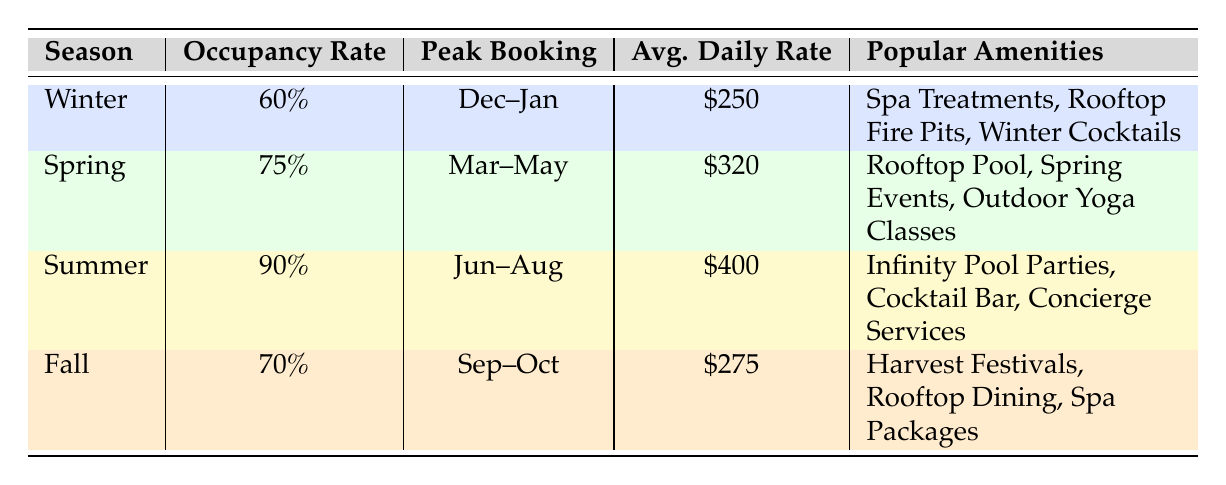What is the average daily rate for Summer? From the table, the Summer season shows an Average Daily Rate of \$400.
Answer: 400 Which season has the highest average occupancy rate? The table indicates that Summer has the highest Average Occupancy Rate of 90%.
Answer: Summer How many popular amenities are listed for Spring? The Spring season has three popular amenities listed: Rooftop Pool, Spring Events, and Outdoor Yoga Classes.
Answer: 3 What is the difference in average daily rates between Spring and Fall? The Average Daily Rate for Spring is \$320, while for Fall it is \$275. To find the difference: 320 - 275 = 45.
Answer: 45 Is it true that couples are common guests during Winter? The table lists Couples as one of the Common Guest Demographics for Winter, confirming the statement is true.
Answer: Yes What are the most popular amenities for the Fall season? The table lists Harvest Festivals, Rooftop Dining, and Spa Packages as popular amenities for Fall.
Answer: Harvest Festivals, Rooftop Dining, Spa Packages During which peak booking period does the Winter season occur? The table states that the Peak Booking Period for Winter is from December to January.
Answer: December to January What is the average occupancy rate for all seasons combined? The Average Occupancy Rates are as follows: Winter 60%, Spring 75%, Summer 90%, and Fall 70%. To calculate the average: (60 + 75 + 90 + 70) / 4 = 73.75.
Answer: 73.75 How do luxury travelers prefer to spend their time in Summer? The Common Guest Demographics for Summer include Luxury Travelers, with popular amenities being Infinity Pool Parties, Cocktail Bar, and Concierge Services.
Answer: Infinity Pool Parties, Cocktail Bar, Concierge Services 